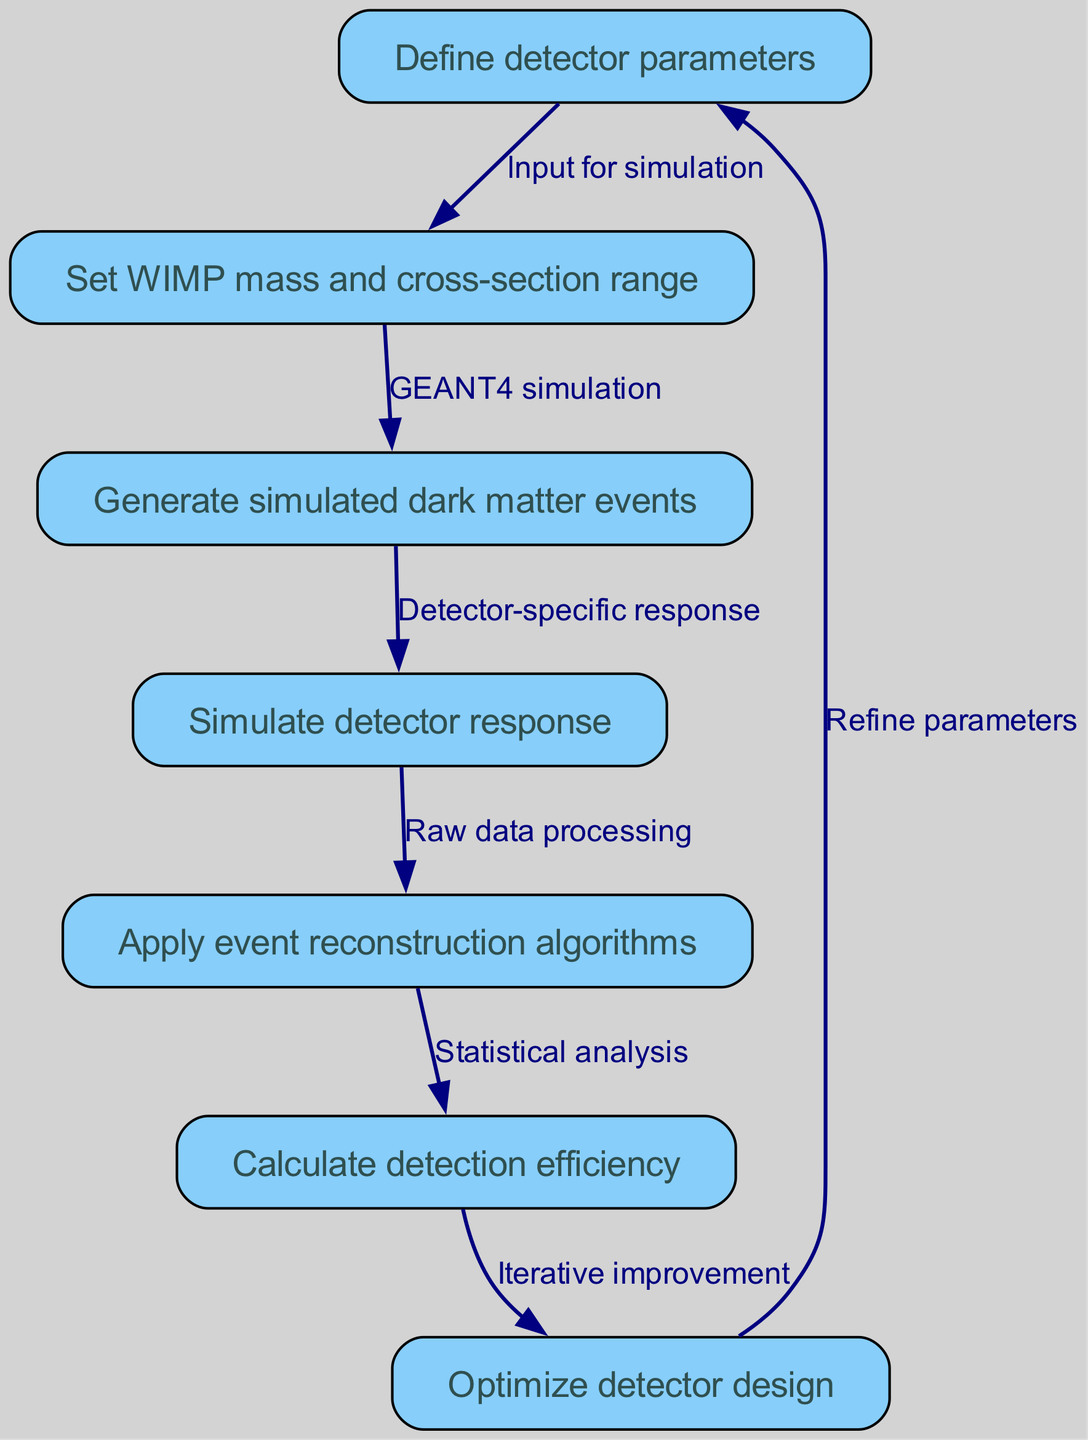What is the first step in the Monte Carlo simulation workflow? The first step in the workflow is "Define detector parameters," which is indicated as node 1 in the diagram. This step sets the groundwork for the subsequent process by determining the specifications that the detector will use.
Answer: Define detector parameters How many nodes are present in the diagram? The diagram contains a total of 7 nodes, each representing a crucial step in the Monte Carlo simulation workflow. Each node can be counted from the list provided in the data.
Answer: 7 What does the edge from node 6 to node 7 represent? The edge from node 6 ("Calculate detection efficiency") to node 7 ("Optimize detector design") signifies "Iterative improvement," indicating that the efficiency calculation feeds back into optimizing the design based on the results obtained.
Answer: Iterative improvement Which node is connected to node 5? Node 5 ("Apply event reconstruction algorithms") is connected to node 6 ("Calculate detection efficiency"). This implies that the reconstruction algorithms' output is necessary to compute the efficiency of detection.
Answer: Calculate detection efficiency What is the direct input for the simulation? The direct input for the simulation is provided by node 1 ("Define detector parameters"), as it starts the workflow by establishing the necessary parameters before proceeding to the next step.
Answer: Define detector parameters What is the relationship between nodes 2 and 3? The relationship between nodes 2 ("Set WIMP mass and cross-section range") and 3 ("Generate simulated dark matter events") is established through "GEANT4 simulation." This implies that the WIMP parameters set in node 2 are used to generate the dark matter events in node 3.
Answer: GEANT4 simulation Which node allows for refinement in the optimization process? Node 7 ("Optimize detector design") allows for refinement in the optimization process, as indicated by the edge that points back to node 1 ("Define detector parameters"), suggesting a loop for continuous improvement based on the design optimization results.
Answer: Optimize detector design 